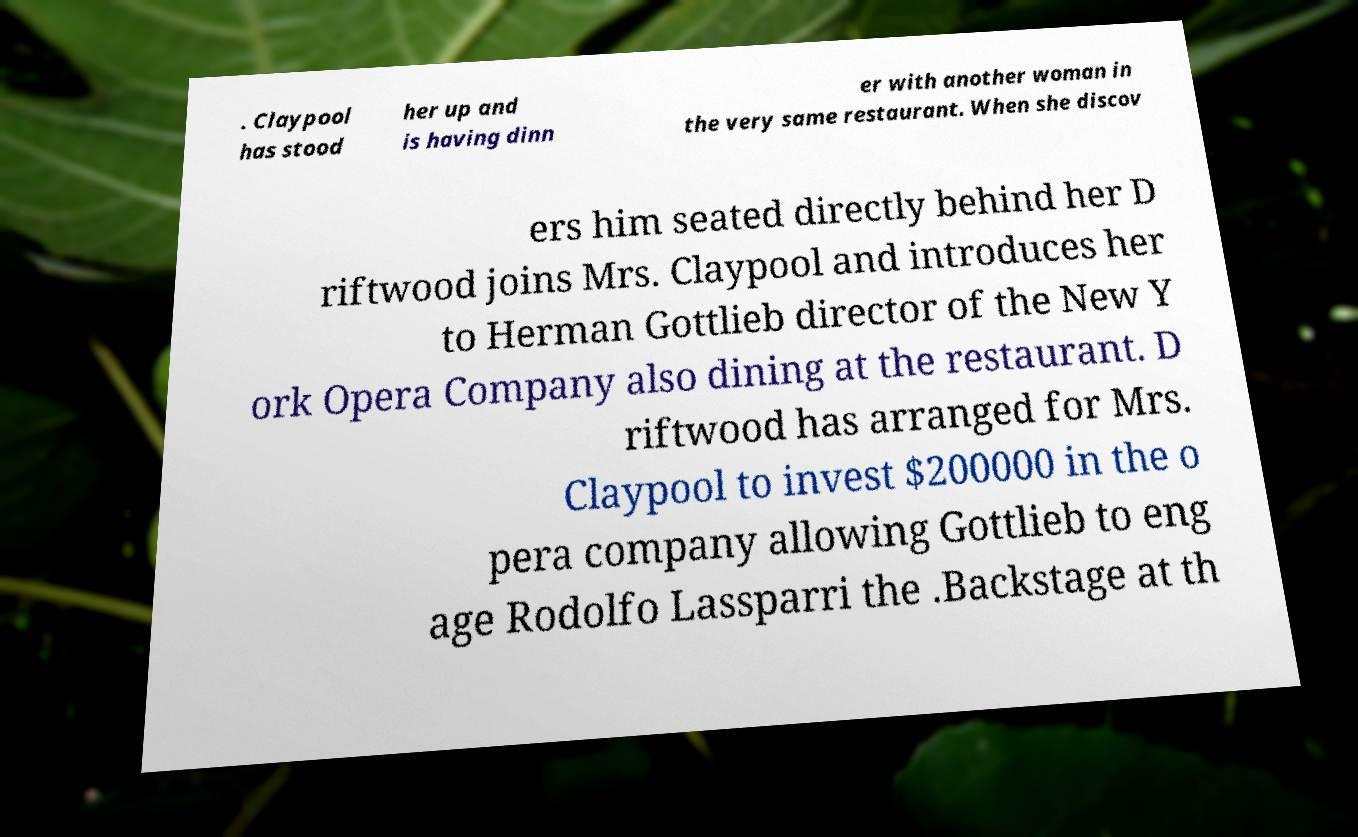For documentation purposes, I need the text within this image transcribed. Could you provide that? . Claypool has stood her up and is having dinn er with another woman in the very same restaurant. When she discov ers him seated directly behind her D riftwood joins Mrs. Claypool and introduces her to Herman Gottlieb director of the New Y ork Opera Company also dining at the restaurant. D riftwood has arranged for Mrs. Claypool to invest $200000 in the o pera company allowing Gottlieb to eng age Rodolfo Lassparri the .Backstage at th 